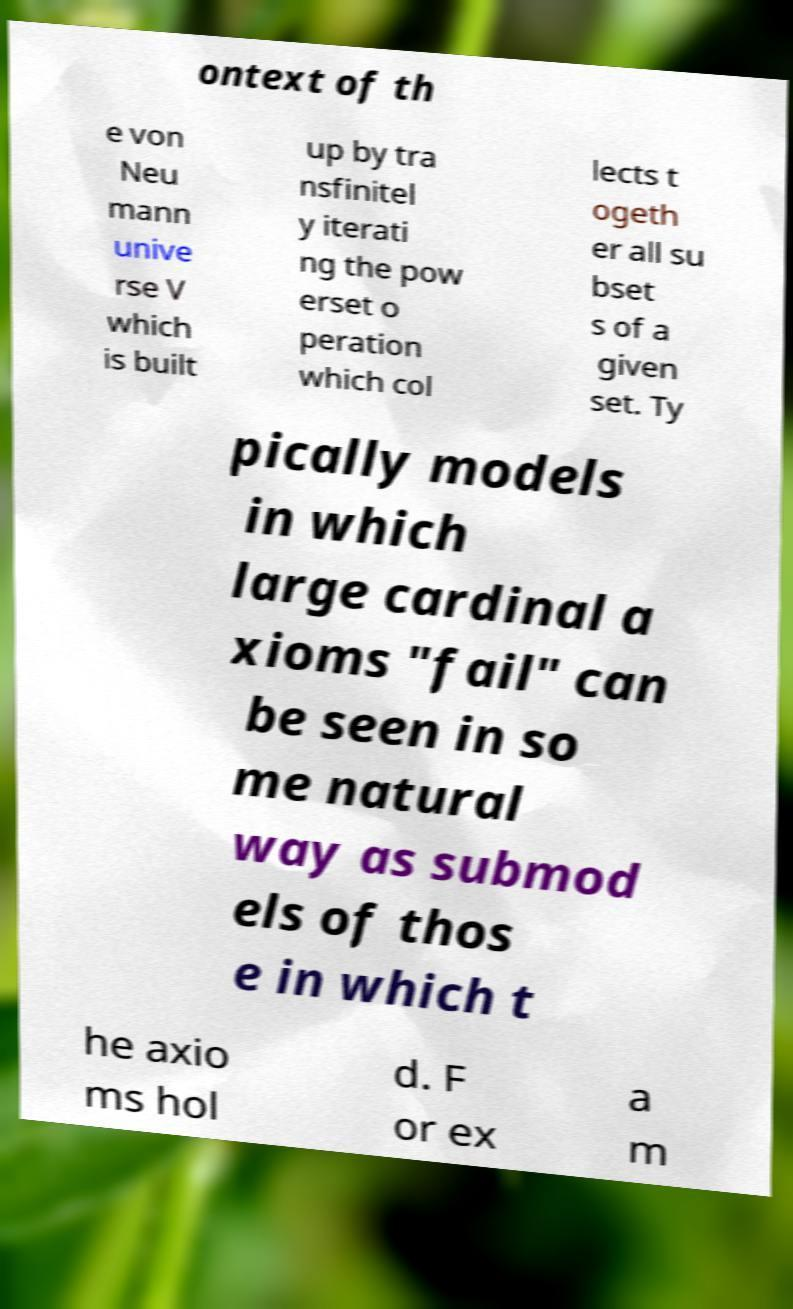What messages or text are displayed in this image? I need them in a readable, typed format. ontext of th e von Neu mann unive rse V which is built up by tra nsfinitel y iterati ng the pow erset o peration which col lects t ogeth er all su bset s of a given set. Ty pically models in which large cardinal a xioms "fail" can be seen in so me natural way as submod els of thos e in which t he axio ms hol d. F or ex a m 